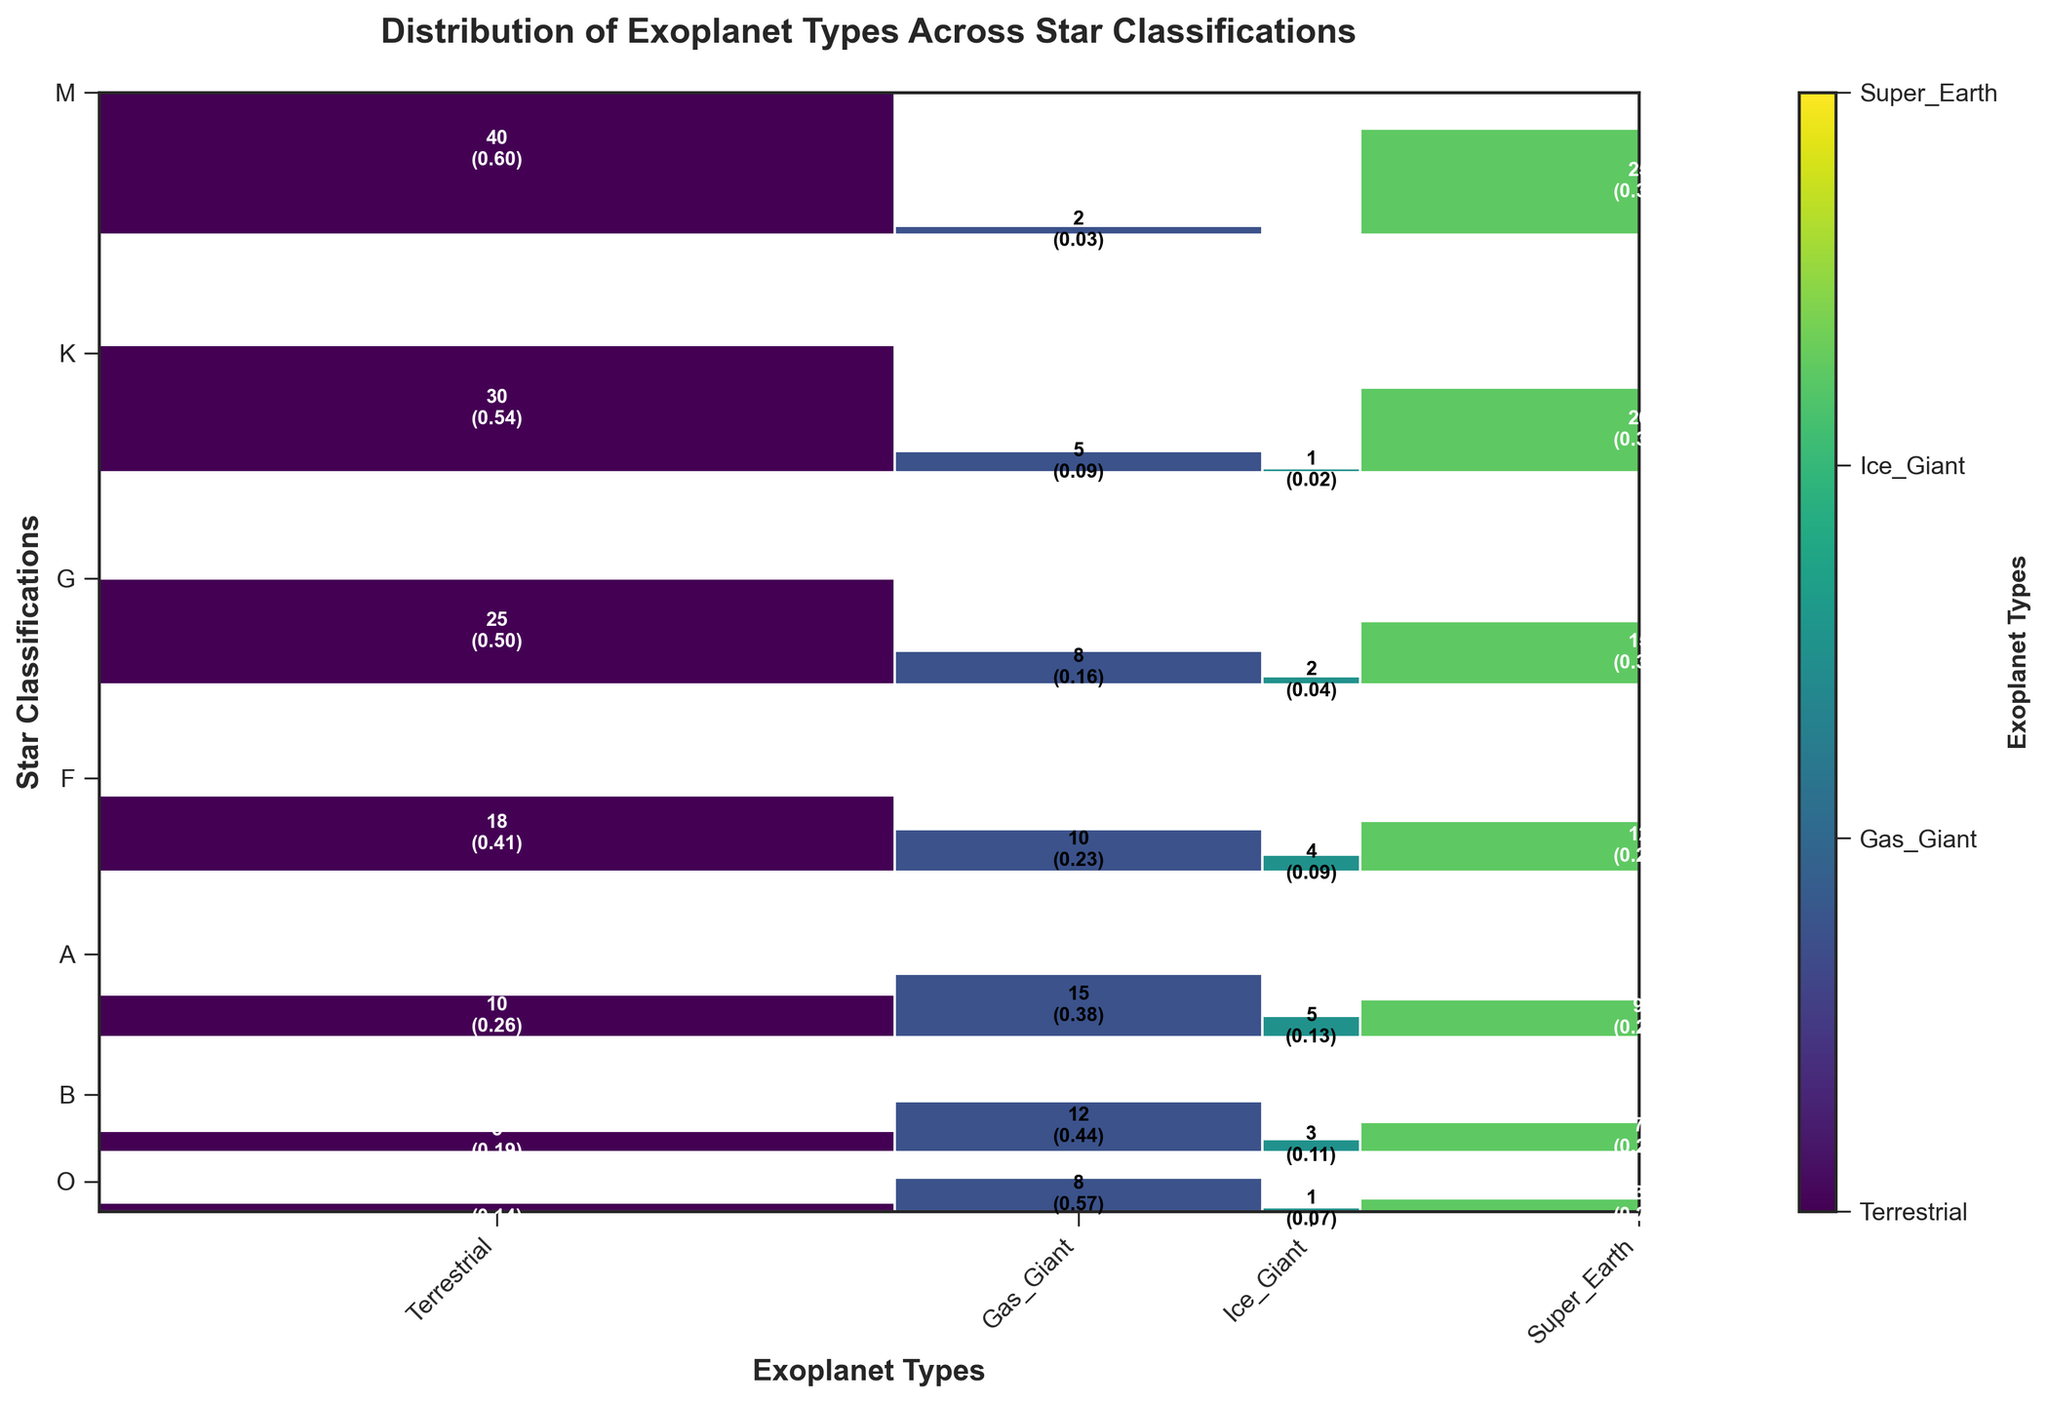Which star classification has the highest number of terrestrial planets? Look at the mosaic plot and find the star classification with the largest rectangle in the "Terrestrial" column. The tallest bar indicates the highest count.
Answer: M Which exoplanet type is most common overall in the dataset? The width of the mosaic plot blocks corresponds to the number of each exoplanet type across all star classifications. The widest block represents the most common type.
Answer: Terrestrial Between K and G star classifications, which has more Super-Earths? Compare the height of the bars in the "Super_Earth" column for K and G star classifications. The taller bar has more Super-Earths.
Answer: K What is the total number of Gas Giants across all star classifications? Sum the individual counts for Gas Giants across all star classifications: 8 + 12 + 15 + 10 + 8 + 5 + 2.
Answer: 60 Which star classification has the least variety of exoplanets? Variety can be assessed by the number of different exoplanet types with non-zero counts. Look at the row with the fewest different types in the plot.
Answer: M How many star classifications have more than 10 terrestrial planets? Count the rows where the height of the bar for "Terrestrial" exceeds 10.
Answer: 4 Which planet type is least common around M stars? Look at the M row and find the column with the smallest (or zero) bar height.
Answer: Ice Giant Do O stars have more terrestrial planets or more Super-Earths? Compare the heights in the "O" row under the "Terrestrial" and "Super_Earth" columns.
Answer: Super-Earths What's the difference in the count of Ice Giants between B and A star classifications? Subtract the count of Ice Giants in A from the count in B: 3 - 5.
Answer: 2 Among terrestrial, gas giant, ice giant, and super earth, which planet type is proportionally highest in F stars? Look at the normalized values in the F row and identify the column with the highest proportional value.
Answer: Terrestrial 